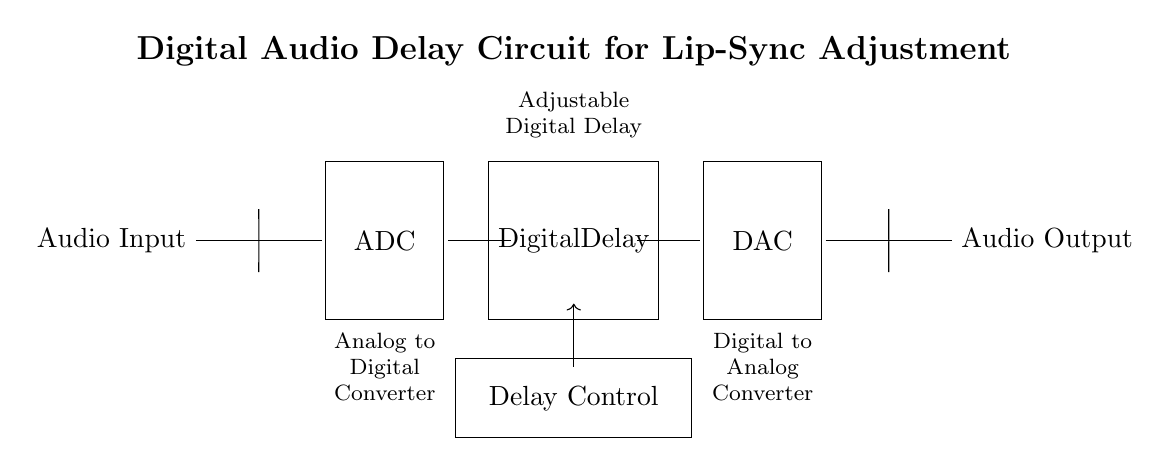What is the first component in the circuit? The first component is the audio input, which is the point where the audio signal enters the circuit. It is located at the far left side of the diagram.
Answer: Audio Input What type of conversion occurs at the ADC? The ADC (Analog to Digital Converter) performs the conversion of the analog audio input signal into a digital format. This is crucial for processing the audio signal digitally in the subsequent stages of the circuit.
Answer: Analog to Digital What is the function of the Digital Delay component? The Digital Delay component introduces a timed delay to the audio signal, allowing for lip-sync adjustment by aligning the audio and video playback. It receives the digital audio signal from the ADC and processes it accordingly.
Answer: Lip-sync adjustment How many main stages are there in this circuit? There are three main stages: the ADC, the Digital Delay, and the DAC. Each stage serves a specific function in processing the audio signal from input to output.
Answer: Three What controls the delay in the Digital Delay section? The delay control component provides the user interface to adjust the amount of delay applied to the audio signal passing through the digital delay. It effectively allows users to synchronize audio playback with video.
Answer: Delay Control What is the last component in the circuit used for? The last component, the DAC (Digital to Analog Converter), converts the processed digital audio signal back into an analog format, allowing it to be output as auditory sound that can be played through speakers.
Answer: Audio Output What is the purpose of including a Digital Delay in localized films? The Digital Delay is necessary in localized films to ensure that the audio matches the movements of the characters' lips, maintaining immersion and narrative coherence for the audience.
Answer: Lip-sync adjustment 